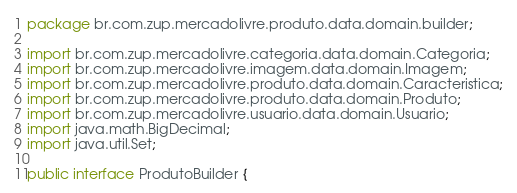<code> <loc_0><loc_0><loc_500><loc_500><_Java_>package br.com.zup.mercadolivre.produto.data.domain.builder;

import br.com.zup.mercadolivre.categoria.data.domain.Categoria;
import br.com.zup.mercadolivre.imagem.data.domain.Imagem;
import br.com.zup.mercadolivre.produto.data.domain.Caracteristica;
import br.com.zup.mercadolivre.produto.data.domain.Produto;
import br.com.zup.mercadolivre.usuario.data.domain.Usuario;
import java.math.BigDecimal;
import java.util.Set;

public interface ProdutoBuilder {
</code> 